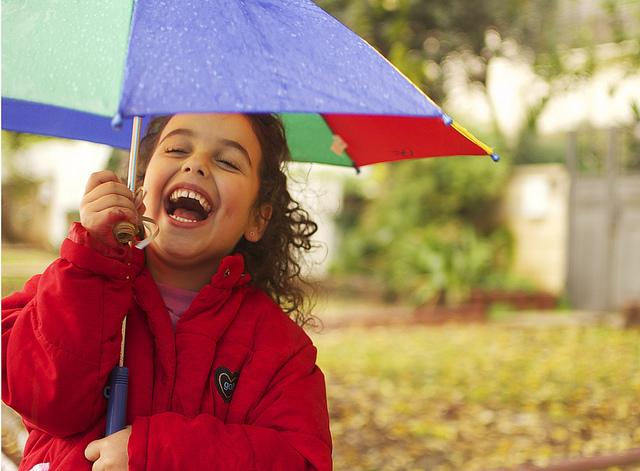What is the little girl holding?
Quick response, please. Umbrella. Is it raining outside?
Short answer required. Yes. What is the girl holding in her hand?
Write a very short answer. Umbrella. Is this girl sad?
Short answer required. No. 